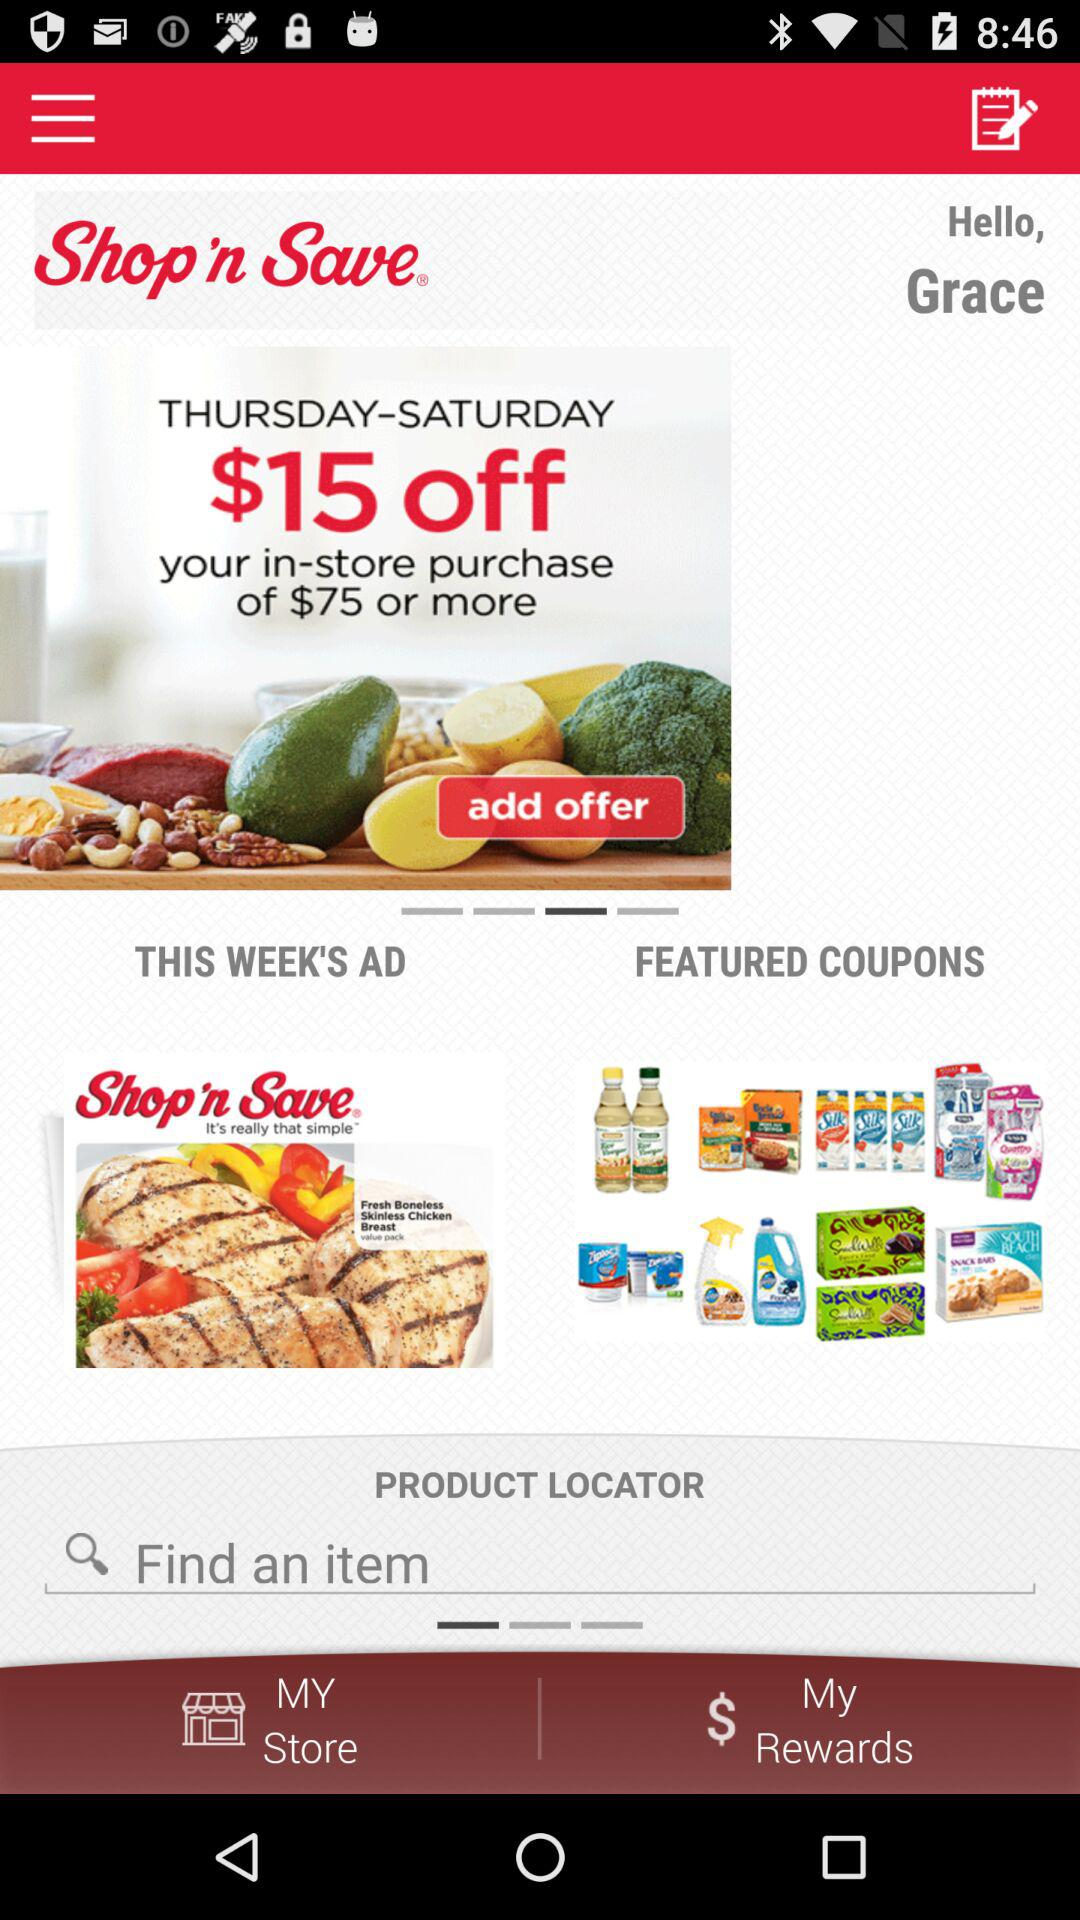What is the user name? The user name is Grace. 